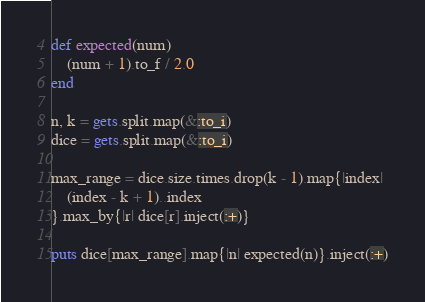<code> <loc_0><loc_0><loc_500><loc_500><_Ruby_>def expected(num)
    (num + 1).to_f / 2.0
end

n, k = gets.split.map(&:to_i)
dice = gets.split.map(&:to_i)

max_range = dice.size.times.drop(k - 1).map{|index|
    (index - k + 1)..index
}.max_by{|r| dice[r].inject(:+)}

puts dice[max_range].map{|n| expected(n)}.inject(:+)
</code> 